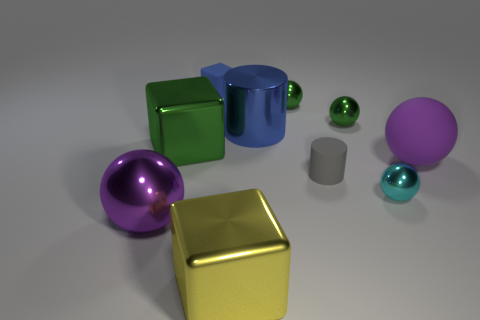Subtract all blue balls. Subtract all red cubes. How many balls are left? 5 Subtract all cubes. How many objects are left? 7 Subtract 1 yellow blocks. How many objects are left? 9 Subtract all brown rubber cubes. Subtract all yellow cubes. How many objects are left? 9 Add 2 tiny balls. How many tiny balls are left? 5 Add 8 blue metallic cylinders. How many blue metallic cylinders exist? 9 